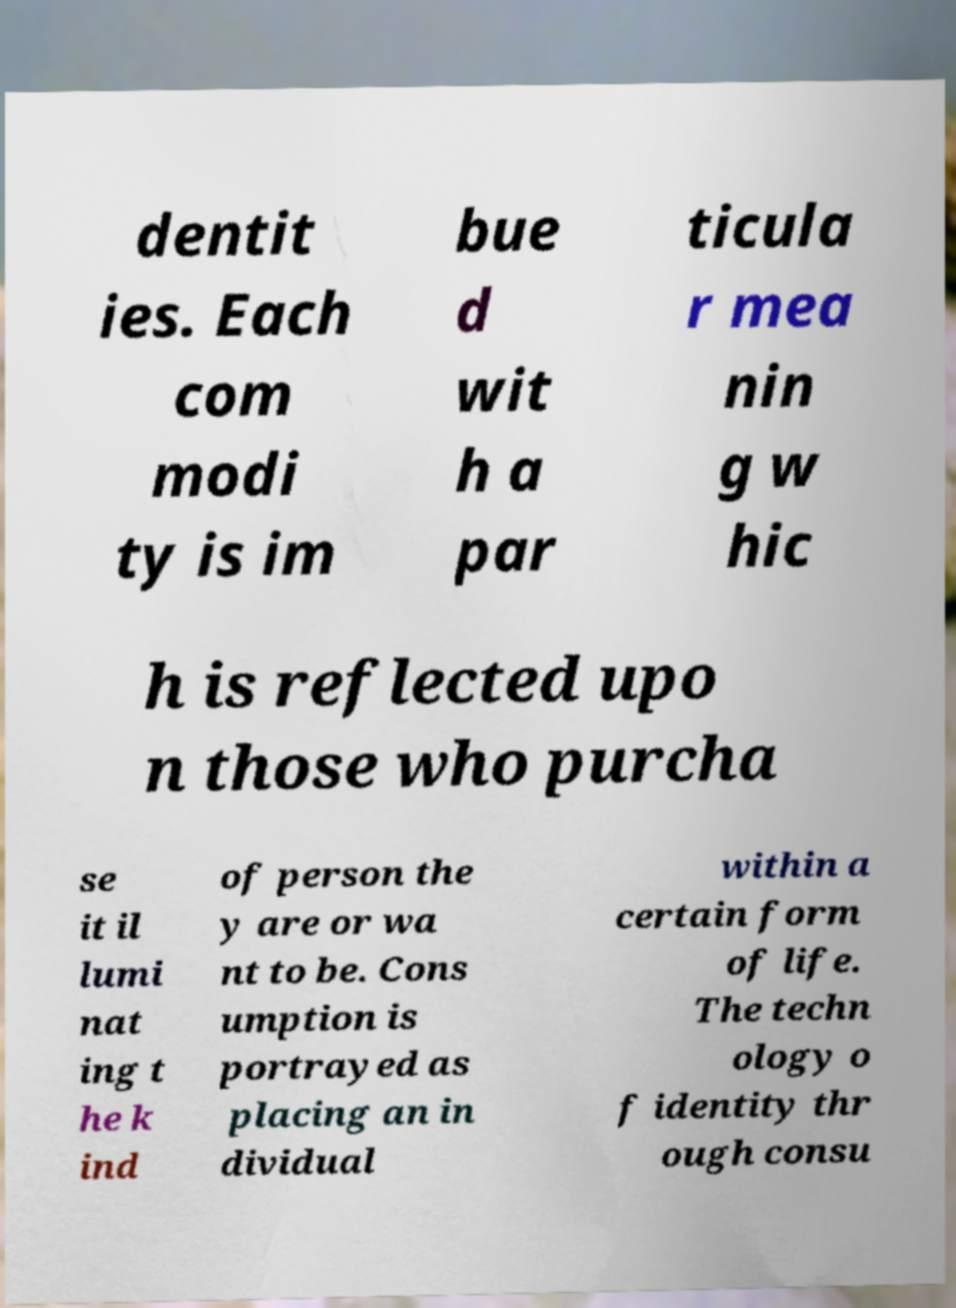There's text embedded in this image that I need extracted. Can you transcribe it verbatim? dentit ies. Each com modi ty is im bue d wit h a par ticula r mea nin g w hic h is reflected upo n those who purcha se it il lumi nat ing t he k ind of person the y are or wa nt to be. Cons umption is portrayed as placing an in dividual within a certain form of life. The techn ology o f identity thr ough consu 